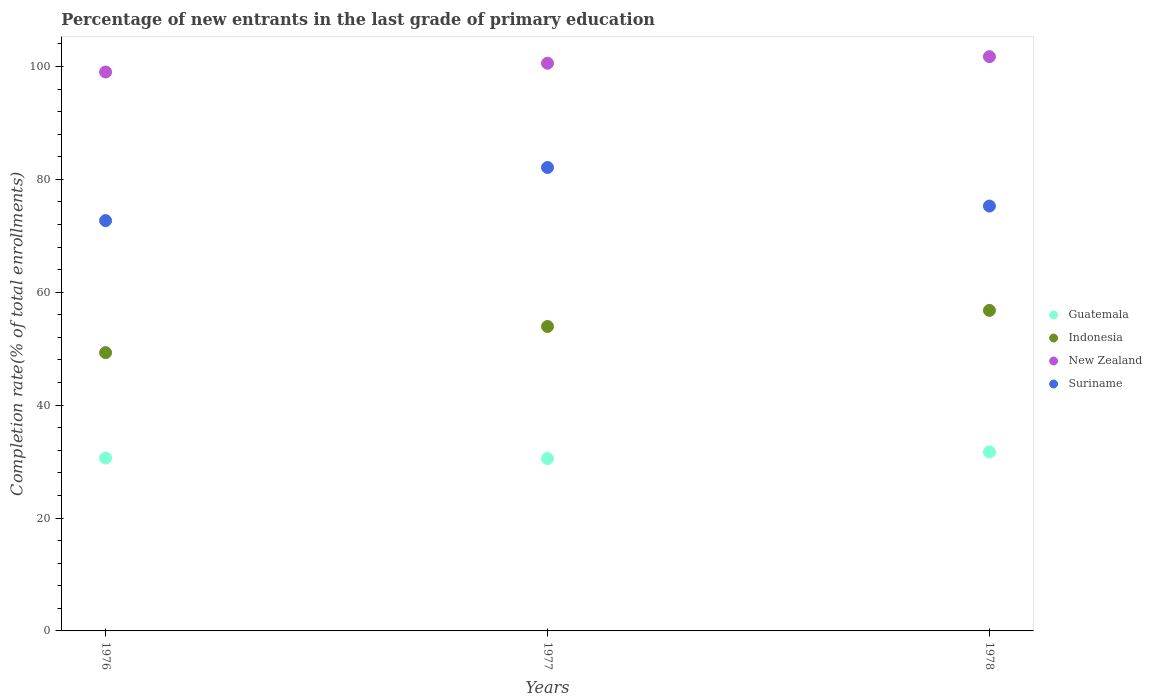How many different coloured dotlines are there?
Your answer should be compact. 4. What is the percentage of new entrants in Suriname in 1976?
Offer a very short reply. 72.69. Across all years, what is the maximum percentage of new entrants in Indonesia?
Your answer should be very brief. 56.79. Across all years, what is the minimum percentage of new entrants in Guatemala?
Provide a succinct answer. 30.53. In which year was the percentage of new entrants in Suriname minimum?
Ensure brevity in your answer.  1976. What is the total percentage of new entrants in Guatemala in the graph?
Provide a short and direct response. 92.87. What is the difference between the percentage of new entrants in New Zealand in 1977 and that in 1978?
Keep it short and to the point. -1.16. What is the difference between the percentage of new entrants in Suriname in 1978 and the percentage of new entrants in Guatemala in 1977?
Offer a terse response. 44.74. What is the average percentage of new entrants in Indonesia per year?
Your response must be concise. 53.34. In the year 1976, what is the difference between the percentage of new entrants in Indonesia and percentage of new entrants in Suriname?
Your answer should be very brief. -23.39. What is the ratio of the percentage of new entrants in Indonesia in 1976 to that in 1978?
Offer a very short reply. 0.87. What is the difference between the highest and the second highest percentage of new entrants in Suriname?
Offer a terse response. 6.84. What is the difference between the highest and the lowest percentage of new entrants in New Zealand?
Offer a terse response. 2.72. Is it the case that in every year, the sum of the percentage of new entrants in New Zealand and percentage of new entrants in Suriname  is greater than the sum of percentage of new entrants in Indonesia and percentage of new entrants in Guatemala?
Offer a terse response. Yes. Is it the case that in every year, the sum of the percentage of new entrants in Suriname and percentage of new entrants in Indonesia  is greater than the percentage of new entrants in Guatemala?
Your answer should be compact. Yes. Does the percentage of new entrants in Indonesia monotonically increase over the years?
Keep it short and to the point. Yes. Is the percentage of new entrants in New Zealand strictly greater than the percentage of new entrants in Suriname over the years?
Provide a short and direct response. Yes. Is the percentage of new entrants in New Zealand strictly less than the percentage of new entrants in Suriname over the years?
Keep it short and to the point. No. How many dotlines are there?
Your answer should be very brief. 4. Does the graph contain any zero values?
Keep it short and to the point. No. How are the legend labels stacked?
Your answer should be very brief. Vertical. What is the title of the graph?
Your response must be concise. Percentage of new entrants in the last grade of primary education. Does "Slovenia" appear as one of the legend labels in the graph?
Provide a succinct answer. No. What is the label or title of the X-axis?
Your answer should be very brief. Years. What is the label or title of the Y-axis?
Your answer should be very brief. Completion rate(% of total enrollments). What is the Completion rate(% of total enrollments) of Guatemala in 1976?
Make the answer very short. 30.63. What is the Completion rate(% of total enrollments) of Indonesia in 1976?
Your answer should be compact. 49.3. What is the Completion rate(% of total enrollments) in New Zealand in 1976?
Provide a short and direct response. 99.02. What is the Completion rate(% of total enrollments) of Suriname in 1976?
Your response must be concise. 72.69. What is the Completion rate(% of total enrollments) in Guatemala in 1977?
Offer a very short reply. 30.53. What is the Completion rate(% of total enrollments) of Indonesia in 1977?
Provide a short and direct response. 53.94. What is the Completion rate(% of total enrollments) in New Zealand in 1977?
Offer a terse response. 100.57. What is the Completion rate(% of total enrollments) in Suriname in 1977?
Your answer should be very brief. 82.11. What is the Completion rate(% of total enrollments) of Guatemala in 1978?
Ensure brevity in your answer.  31.71. What is the Completion rate(% of total enrollments) of Indonesia in 1978?
Make the answer very short. 56.79. What is the Completion rate(% of total enrollments) of New Zealand in 1978?
Offer a terse response. 101.74. What is the Completion rate(% of total enrollments) in Suriname in 1978?
Offer a very short reply. 75.27. Across all years, what is the maximum Completion rate(% of total enrollments) in Guatemala?
Make the answer very short. 31.71. Across all years, what is the maximum Completion rate(% of total enrollments) in Indonesia?
Offer a terse response. 56.79. Across all years, what is the maximum Completion rate(% of total enrollments) in New Zealand?
Offer a terse response. 101.74. Across all years, what is the maximum Completion rate(% of total enrollments) of Suriname?
Give a very brief answer. 82.11. Across all years, what is the minimum Completion rate(% of total enrollments) of Guatemala?
Ensure brevity in your answer.  30.53. Across all years, what is the minimum Completion rate(% of total enrollments) in Indonesia?
Keep it short and to the point. 49.3. Across all years, what is the minimum Completion rate(% of total enrollments) in New Zealand?
Provide a succinct answer. 99.02. Across all years, what is the minimum Completion rate(% of total enrollments) in Suriname?
Offer a very short reply. 72.69. What is the total Completion rate(% of total enrollments) of Guatemala in the graph?
Your answer should be compact. 92.87. What is the total Completion rate(% of total enrollments) of Indonesia in the graph?
Keep it short and to the point. 160.02. What is the total Completion rate(% of total enrollments) of New Zealand in the graph?
Ensure brevity in your answer.  301.33. What is the total Completion rate(% of total enrollments) in Suriname in the graph?
Your answer should be compact. 230.07. What is the difference between the Completion rate(% of total enrollments) of Guatemala in 1976 and that in 1977?
Offer a very short reply. 0.1. What is the difference between the Completion rate(% of total enrollments) of Indonesia in 1976 and that in 1977?
Give a very brief answer. -4.64. What is the difference between the Completion rate(% of total enrollments) of New Zealand in 1976 and that in 1977?
Give a very brief answer. -1.55. What is the difference between the Completion rate(% of total enrollments) in Suriname in 1976 and that in 1977?
Give a very brief answer. -9.42. What is the difference between the Completion rate(% of total enrollments) of Guatemala in 1976 and that in 1978?
Provide a short and direct response. -1.07. What is the difference between the Completion rate(% of total enrollments) in Indonesia in 1976 and that in 1978?
Your answer should be compact. -7.49. What is the difference between the Completion rate(% of total enrollments) in New Zealand in 1976 and that in 1978?
Your answer should be very brief. -2.72. What is the difference between the Completion rate(% of total enrollments) in Suriname in 1976 and that in 1978?
Keep it short and to the point. -2.58. What is the difference between the Completion rate(% of total enrollments) of Guatemala in 1977 and that in 1978?
Offer a terse response. -1.17. What is the difference between the Completion rate(% of total enrollments) of Indonesia in 1977 and that in 1978?
Your response must be concise. -2.85. What is the difference between the Completion rate(% of total enrollments) in New Zealand in 1977 and that in 1978?
Your answer should be compact. -1.16. What is the difference between the Completion rate(% of total enrollments) of Suriname in 1977 and that in 1978?
Your answer should be very brief. 6.84. What is the difference between the Completion rate(% of total enrollments) of Guatemala in 1976 and the Completion rate(% of total enrollments) of Indonesia in 1977?
Your answer should be very brief. -23.31. What is the difference between the Completion rate(% of total enrollments) of Guatemala in 1976 and the Completion rate(% of total enrollments) of New Zealand in 1977?
Keep it short and to the point. -69.94. What is the difference between the Completion rate(% of total enrollments) in Guatemala in 1976 and the Completion rate(% of total enrollments) in Suriname in 1977?
Provide a succinct answer. -51.48. What is the difference between the Completion rate(% of total enrollments) in Indonesia in 1976 and the Completion rate(% of total enrollments) in New Zealand in 1977?
Give a very brief answer. -51.28. What is the difference between the Completion rate(% of total enrollments) of Indonesia in 1976 and the Completion rate(% of total enrollments) of Suriname in 1977?
Provide a succinct answer. -32.81. What is the difference between the Completion rate(% of total enrollments) in New Zealand in 1976 and the Completion rate(% of total enrollments) in Suriname in 1977?
Your answer should be very brief. 16.91. What is the difference between the Completion rate(% of total enrollments) of Guatemala in 1976 and the Completion rate(% of total enrollments) of Indonesia in 1978?
Keep it short and to the point. -26.15. What is the difference between the Completion rate(% of total enrollments) of Guatemala in 1976 and the Completion rate(% of total enrollments) of New Zealand in 1978?
Ensure brevity in your answer.  -71.11. What is the difference between the Completion rate(% of total enrollments) of Guatemala in 1976 and the Completion rate(% of total enrollments) of Suriname in 1978?
Offer a very short reply. -44.64. What is the difference between the Completion rate(% of total enrollments) of Indonesia in 1976 and the Completion rate(% of total enrollments) of New Zealand in 1978?
Offer a terse response. -52.44. What is the difference between the Completion rate(% of total enrollments) of Indonesia in 1976 and the Completion rate(% of total enrollments) of Suriname in 1978?
Your answer should be very brief. -25.97. What is the difference between the Completion rate(% of total enrollments) of New Zealand in 1976 and the Completion rate(% of total enrollments) of Suriname in 1978?
Ensure brevity in your answer.  23.75. What is the difference between the Completion rate(% of total enrollments) in Guatemala in 1977 and the Completion rate(% of total enrollments) in Indonesia in 1978?
Your answer should be compact. -26.25. What is the difference between the Completion rate(% of total enrollments) in Guatemala in 1977 and the Completion rate(% of total enrollments) in New Zealand in 1978?
Offer a terse response. -71.2. What is the difference between the Completion rate(% of total enrollments) of Guatemala in 1977 and the Completion rate(% of total enrollments) of Suriname in 1978?
Provide a short and direct response. -44.74. What is the difference between the Completion rate(% of total enrollments) in Indonesia in 1977 and the Completion rate(% of total enrollments) in New Zealand in 1978?
Your response must be concise. -47.8. What is the difference between the Completion rate(% of total enrollments) in Indonesia in 1977 and the Completion rate(% of total enrollments) in Suriname in 1978?
Your answer should be compact. -21.33. What is the difference between the Completion rate(% of total enrollments) in New Zealand in 1977 and the Completion rate(% of total enrollments) in Suriname in 1978?
Provide a short and direct response. 25.3. What is the average Completion rate(% of total enrollments) of Guatemala per year?
Ensure brevity in your answer.  30.96. What is the average Completion rate(% of total enrollments) in Indonesia per year?
Provide a succinct answer. 53.34. What is the average Completion rate(% of total enrollments) in New Zealand per year?
Your answer should be very brief. 100.44. What is the average Completion rate(% of total enrollments) of Suriname per year?
Your answer should be very brief. 76.69. In the year 1976, what is the difference between the Completion rate(% of total enrollments) in Guatemala and Completion rate(% of total enrollments) in Indonesia?
Your answer should be very brief. -18.67. In the year 1976, what is the difference between the Completion rate(% of total enrollments) in Guatemala and Completion rate(% of total enrollments) in New Zealand?
Ensure brevity in your answer.  -68.39. In the year 1976, what is the difference between the Completion rate(% of total enrollments) in Guatemala and Completion rate(% of total enrollments) in Suriname?
Give a very brief answer. -42.06. In the year 1976, what is the difference between the Completion rate(% of total enrollments) of Indonesia and Completion rate(% of total enrollments) of New Zealand?
Your answer should be very brief. -49.72. In the year 1976, what is the difference between the Completion rate(% of total enrollments) of Indonesia and Completion rate(% of total enrollments) of Suriname?
Your answer should be compact. -23.39. In the year 1976, what is the difference between the Completion rate(% of total enrollments) in New Zealand and Completion rate(% of total enrollments) in Suriname?
Your answer should be very brief. 26.33. In the year 1977, what is the difference between the Completion rate(% of total enrollments) of Guatemala and Completion rate(% of total enrollments) of Indonesia?
Give a very brief answer. -23.4. In the year 1977, what is the difference between the Completion rate(% of total enrollments) of Guatemala and Completion rate(% of total enrollments) of New Zealand?
Your response must be concise. -70.04. In the year 1977, what is the difference between the Completion rate(% of total enrollments) of Guatemala and Completion rate(% of total enrollments) of Suriname?
Your answer should be compact. -51.57. In the year 1977, what is the difference between the Completion rate(% of total enrollments) of Indonesia and Completion rate(% of total enrollments) of New Zealand?
Provide a succinct answer. -46.64. In the year 1977, what is the difference between the Completion rate(% of total enrollments) of Indonesia and Completion rate(% of total enrollments) of Suriname?
Ensure brevity in your answer.  -28.17. In the year 1977, what is the difference between the Completion rate(% of total enrollments) of New Zealand and Completion rate(% of total enrollments) of Suriname?
Your answer should be compact. 18.47. In the year 1978, what is the difference between the Completion rate(% of total enrollments) in Guatemala and Completion rate(% of total enrollments) in Indonesia?
Offer a very short reply. -25.08. In the year 1978, what is the difference between the Completion rate(% of total enrollments) of Guatemala and Completion rate(% of total enrollments) of New Zealand?
Give a very brief answer. -70.03. In the year 1978, what is the difference between the Completion rate(% of total enrollments) in Guatemala and Completion rate(% of total enrollments) in Suriname?
Your response must be concise. -43.57. In the year 1978, what is the difference between the Completion rate(% of total enrollments) in Indonesia and Completion rate(% of total enrollments) in New Zealand?
Provide a succinct answer. -44.95. In the year 1978, what is the difference between the Completion rate(% of total enrollments) of Indonesia and Completion rate(% of total enrollments) of Suriname?
Give a very brief answer. -18.49. In the year 1978, what is the difference between the Completion rate(% of total enrollments) in New Zealand and Completion rate(% of total enrollments) in Suriname?
Your answer should be very brief. 26.47. What is the ratio of the Completion rate(% of total enrollments) of Indonesia in 1976 to that in 1977?
Provide a short and direct response. 0.91. What is the ratio of the Completion rate(% of total enrollments) in New Zealand in 1976 to that in 1977?
Your answer should be compact. 0.98. What is the ratio of the Completion rate(% of total enrollments) in Suriname in 1976 to that in 1977?
Ensure brevity in your answer.  0.89. What is the ratio of the Completion rate(% of total enrollments) in Guatemala in 1976 to that in 1978?
Your answer should be very brief. 0.97. What is the ratio of the Completion rate(% of total enrollments) in Indonesia in 1976 to that in 1978?
Give a very brief answer. 0.87. What is the ratio of the Completion rate(% of total enrollments) in New Zealand in 1976 to that in 1978?
Provide a succinct answer. 0.97. What is the ratio of the Completion rate(% of total enrollments) of Suriname in 1976 to that in 1978?
Keep it short and to the point. 0.97. What is the ratio of the Completion rate(% of total enrollments) of Guatemala in 1977 to that in 1978?
Give a very brief answer. 0.96. What is the ratio of the Completion rate(% of total enrollments) in Indonesia in 1977 to that in 1978?
Offer a terse response. 0.95. What is the ratio of the Completion rate(% of total enrollments) in Suriname in 1977 to that in 1978?
Your response must be concise. 1.09. What is the difference between the highest and the second highest Completion rate(% of total enrollments) of Guatemala?
Your answer should be compact. 1.07. What is the difference between the highest and the second highest Completion rate(% of total enrollments) in Indonesia?
Make the answer very short. 2.85. What is the difference between the highest and the second highest Completion rate(% of total enrollments) in New Zealand?
Ensure brevity in your answer.  1.16. What is the difference between the highest and the second highest Completion rate(% of total enrollments) in Suriname?
Offer a terse response. 6.84. What is the difference between the highest and the lowest Completion rate(% of total enrollments) of Guatemala?
Provide a short and direct response. 1.17. What is the difference between the highest and the lowest Completion rate(% of total enrollments) in Indonesia?
Give a very brief answer. 7.49. What is the difference between the highest and the lowest Completion rate(% of total enrollments) of New Zealand?
Offer a very short reply. 2.72. What is the difference between the highest and the lowest Completion rate(% of total enrollments) of Suriname?
Keep it short and to the point. 9.42. 